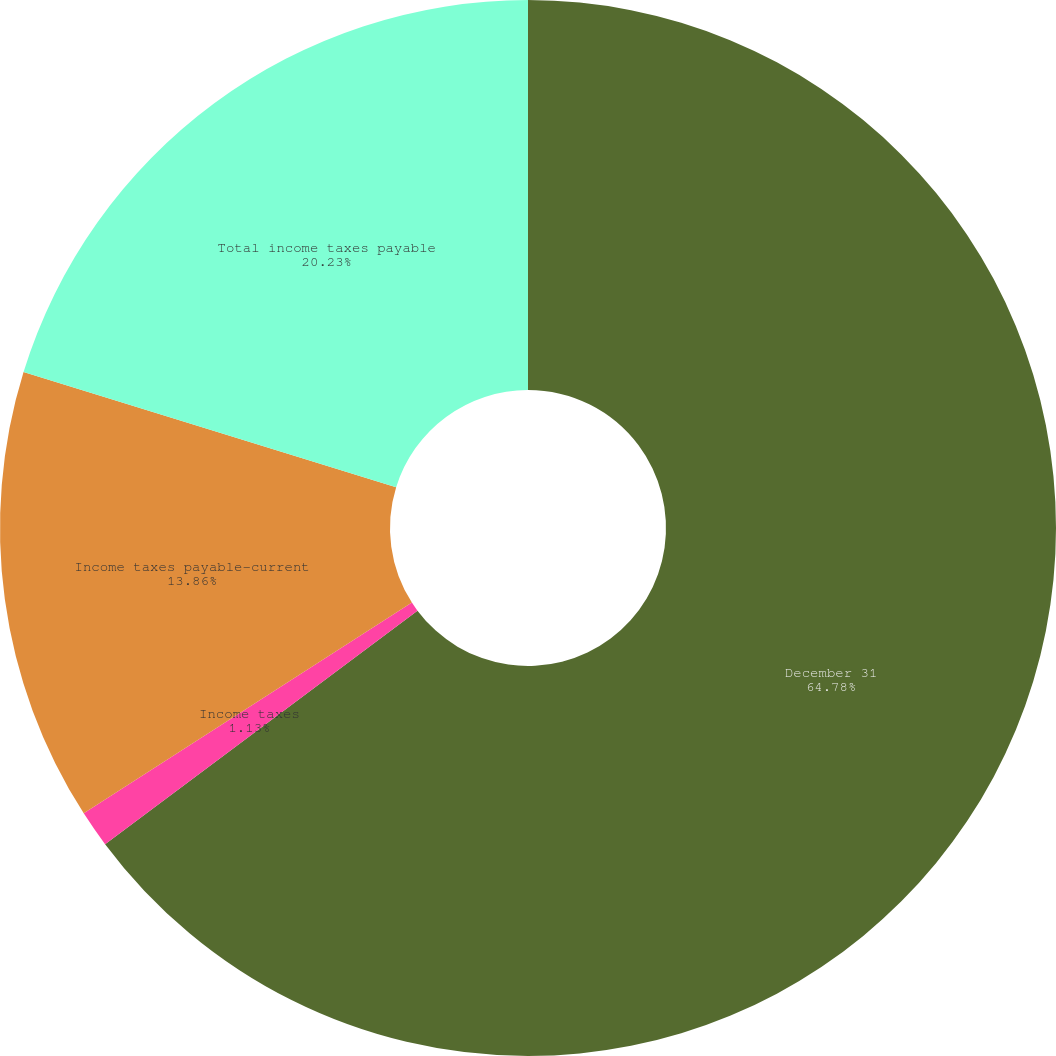Convert chart. <chart><loc_0><loc_0><loc_500><loc_500><pie_chart><fcel>December 31<fcel>Income taxes<fcel>Income taxes payable-current<fcel>Total income taxes payable<nl><fcel>64.79%<fcel>1.13%<fcel>13.86%<fcel>20.23%<nl></chart> 